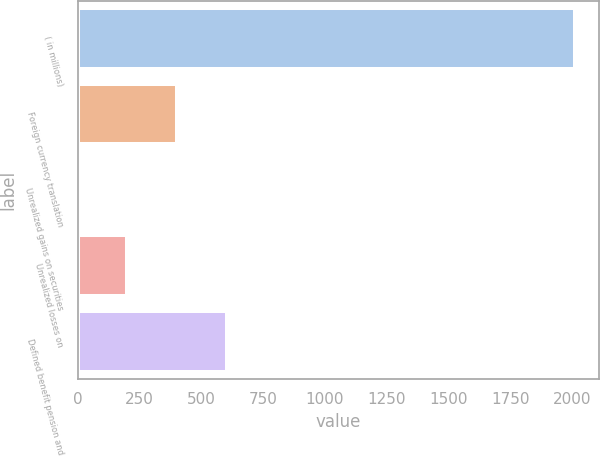Convert chart to OTSL. <chart><loc_0><loc_0><loc_500><loc_500><bar_chart><fcel>( in millions)<fcel>Foreign currency translation<fcel>Unrealized gains on securities<fcel>Unrealized losses on<fcel>Defined benefit pension and<nl><fcel>2011<fcel>402.52<fcel>0.4<fcel>201.46<fcel>603.58<nl></chart> 